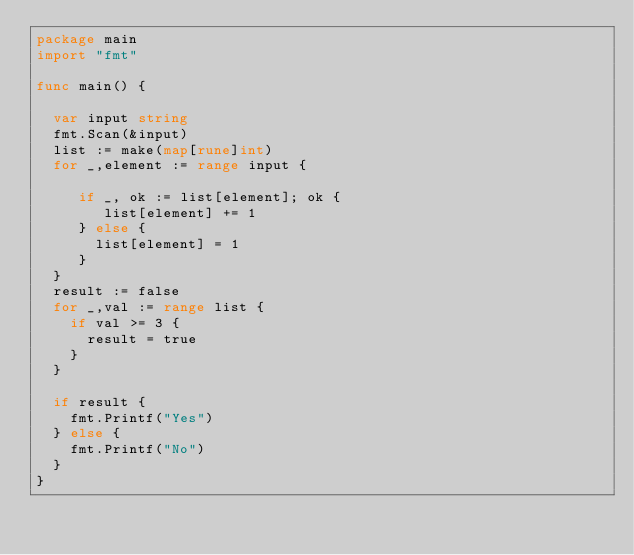<code> <loc_0><loc_0><loc_500><loc_500><_Go_>package main
import "fmt"

func main() {

  var input string
  fmt.Scan(&input)
  list := make(map[rune]int)
  for _,element := range input {
    
  	 if _, ok := list[element]; ok {
        list[element] += 1
     } else {
       list[element] = 1
     }
  }
  result := false
  for _,val := range list {
    if val >= 3 {
      result = true
    }
  }
  
  if result {
    fmt.Printf("Yes")
  } else {
    fmt.Printf("No")
  }
}
</code> 